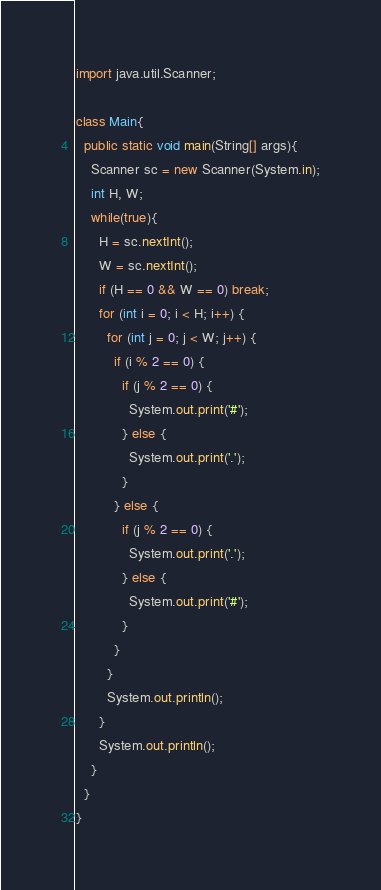<code> <loc_0><loc_0><loc_500><loc_500><_Java_>import java.util.Scanner;

class Main{
  public static void main(String[] args){
    Scanner sc = new Scanner(System.in);
    int H, W;
    while(true){
      H = sc.nextInt();
      W = sc.nextInt();
      if (H == 0 && W == 0) break;
      for (int i = 0; i < H; i++) {
        for (int j = 0; j < W; j++) {
          if (i % 2 == 0) {
            if (j % 2 == 0) {
              System.out.print('#');
            } else {
              System.out.print('.');
            }
          } else {
            if (j % 2 == 0) {
              System.out.print('.');
            } else {
              System.out.print('#');
            }
          }
        }
        System.out.println();
      }
      System.out.println();
    }
  }
}
</code> 